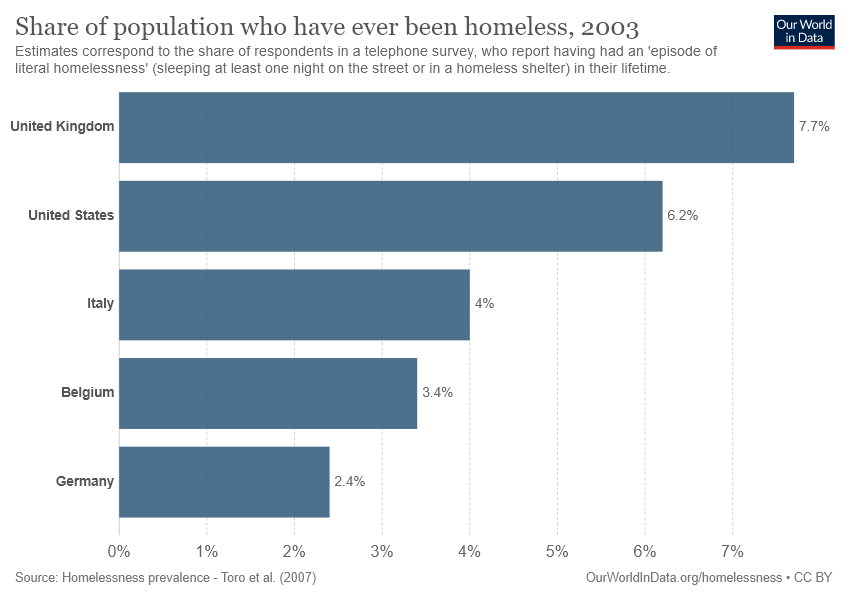Indicate a few pertinent items in this graphic. The sum value of Germany and Belgium is not greater than that of the United States. According to the report, the United Kingdom has the highest percentage of individuals who have experienced literal homelessness in their lifetime. 